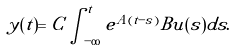Convert formula to latex. <formula><loc_0><loc_0><loc_500><loc_500>y ( t ) = C \int _ { - \infty } ^ { t } e ^ { A ( t - s ) } B u ( s ) d s .</formula> 